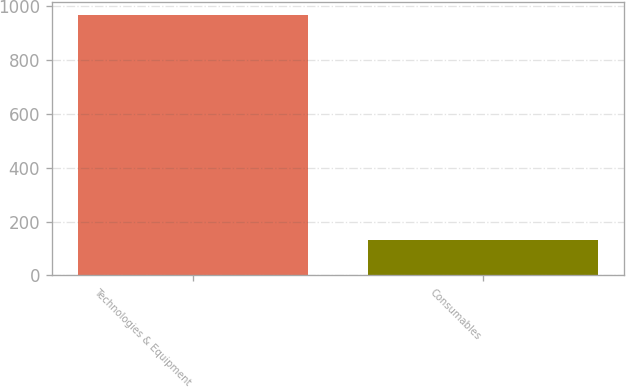Convert chart to OTSL. <chart><loc_0><loc_0><loc_500><loc_500><bar_chart><fcel>Technologies & Equipment<fcel>Consumables<nl><fcel>966.5<fcel>133<nl></chart> 